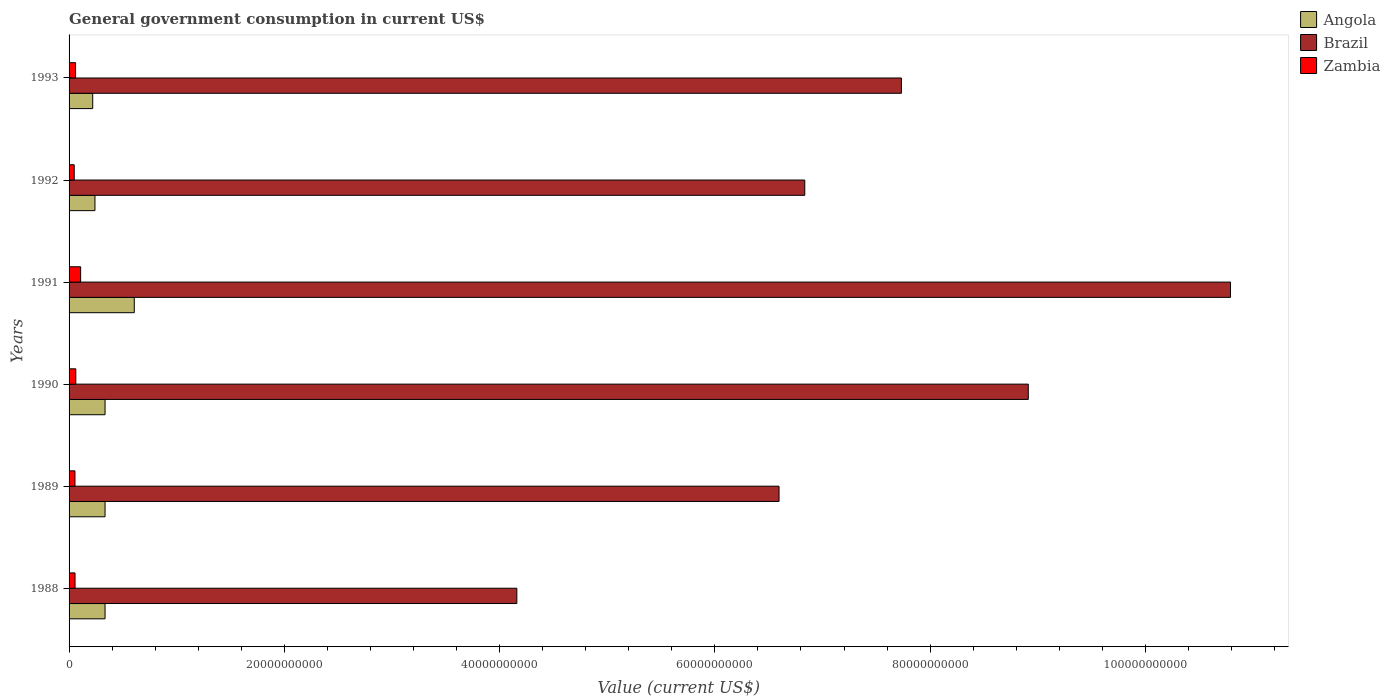Are the number of bars per tick equal to the number of legend labels?
Your response must be concise. Yes. How many bars are there on the 2nd tick from the top?
Your response must be concise. 3. What is the government conusmption in Angola in 1988?
Offer a terse response. 3.34e+09. Across all years, what is the maximum government conusmption in Zambia?
Offer a terse response. 1.07e+09. Across all years, what is the minimum government conusmption in Zambia?
Your answer should be very brief. 4.78e+08. In which year was the government conusmption in Brazil maximum?
Provide a short and direct response. 1991. What is the total government conusmption in Angola in the graph?
Your answer should be very brief. 2.07e+1. What is the difference between the government conusmption in Zambia in 1988 and that in 1992?
Your answer should be compact. 7.66e+07. What is the difference between the government conusmption in Zambia in 1992 and the government conusmption in Brazil in 1991?
Provide a succinct answer. -1.07e+11. What is the average government conusmption in Zambia per year?
Provide a succinct answer. 6.47e+08. In the year 1989, what is the difference between the government conusmption in Angola and government conusmption in Zambia?
Ensure brevity in your answer.  2.79e+09. What is the ratio of the government conusmption in Brazil in 1989 to that in 1993?
Offer a very short reply. 0.85. What is the difference between the highest and the second highest government conusmption in Zambia?
Give a very brief answer. 4.49e+08. What is the difference between the highest and the lowest government conusmption in Angola?
Ensure brevity in your answer.  3.86e+09. Is the sum of the government conusmption in Brazil in 1989 and 1993 greater than the maximum government conusmption in Angola across all years?
Ensure brevity in your answer.  Yes. What does the 1st bar from the top in 1989 represents?
Ensure brevity in your answer.  Zambia. What does the 1st bar from the bottom in 1989 represents?
Offer a terse response. Angola. Is it the case that in every year, the sum of the government conusmption in Zambia and government conusmption in Brazil is greater than the government conusmption in Angola?
Give a very brief answer. Yes. How many bars are there?
Your response must be concise. 18. Are all the bars in the graph horizontal?
Your answer should be very brief. Yes. What is the difference between two consecutive major ticks on the X-axis?
Provide a short and direct response. 2.00e+1. Are the values on the major ticks of X-axis written in scientific E-notation?
Your response must be concise. No. Does the graph contain any zero values?
Provide a short and direct response. No. Does the graph contain grids?
Provide a succinct answer. No. How many legend labels are there?
Provide a short and direct response. 3. What is the title of the graph?
Your answer should be very brief. General government consumption in current US$. What is the label or title of the X-axis?
Provide a succinct answer. Value (current US$). What is the Value (current US$) in Angola in 1988?
Provide a succinct answer. 3.34e+09. What is the Value (current US$) of Brazil in 1988?
Offer a very short reply. 4.16e+1. What is the Value (current US$) of Zambia in 1988?
Your response must be concise. 5.54e+08. What is the Value (current US$) in Angola in 1989?
Provide a short and direct response. 3.34e+09. What is the Value (current US$) of Brazil in 1989?
Provide a short and direct response. 6.60e+1. What is the Value (current US$) of Zambia in 1989?
Make the answer very short. 5.48e+08. What is the Value (current US$) of Angola in 1990?
Your answer should be very brief. 3.34e+09. What is the Value (current US$) of Brazil in 1990?
Your answer should be very brief. 8.91e+1. What is the Value (current US$) in Zambia in 1990?
Keep it short and to the point. 6.26e+08. What is the Value (current US$) in Angola in 1991?
Ensure brevity in your answer.  6.06e+09. What is the Value (current US$) of Brazil in 1991?
Your answer should be compact. 1.08e+11. What is the Value (current US$) in Zambia in 1991?
Offer a terse response. 1.07e+09. What is the Value (current US$) in Angola in 1992?
Your answer should be compact. 2.40e+09. What is the Value (current US$) of Brazil in 1992?
Give a very brief answer. 6.84e+1. What is the Value (current US$) in Zambia in 1992?
Your response must be concise. 4.78e+08. What is the Value (current US$) in Angola in 1993?
Keep it short and to the point. 2.20e+09. What is the Value (current US$) of Brazil in 1993?
Provide a succinct answer. 7.73e+1. What is the Value (current US$) of Zambia in 1993?
Provide a succinct answer. 6.03e+08. Across all years, what is the maximum Value (current US$) of Angola?
Keep it short and to the point. 6.06e+09. Across all years, what is the maximum Value (current US$) in Brazil?
Keep it short and to the point. 1.08e+11. Across all years, what is the maximum Value (current US$) in Zambia?
Your answer should be very brief. 1.07e+09. Across all years, what is the minimum Value (current US$) of Angola?
Your answer should be very brief. 2.20e+09. Across all years, what is the minimum Value (current US$) of Brazil?
Offer a very short reply. 4.16e+1. Across all years, what is the minimum Value (current US$) in Zambia?
Offer a terse response. 4.78e+08. What is the total Value (current US$) of Angola in the graph?
Ensure brevity in your answer.  2.07e+1. What is the total Value (current US$) of Brazil in the graph?
Your answer should be compact. 4.50e+11. What is the total Value (current US$) of Zambia in the graph?
Offer a terse response. 3.88e+09. What is the difference between the Value (current US$) of Angola in 1988 and that in 1989?
Ensure brevity in your answer.  0. What is the difference between the Value (current US$) in Brazil in 1988 and that in 1989?
Provide a short and direct response. -2.44e+1. What is the difference between the Value (current US$) in Zambia in 1988 and that in 1989?
Ensure brevity in your answer.  6.05e+06. What is the difference between the Value (current US$) of Angola in 1988 and that in 1990?
Provide a succinct answer. 0. What is the difference between the Value (current US$) in Brazil in 1988 and that in 1990?
Ensure brevity in your answer.  -4.75e+1. What is the difference between the Value (current US$) in Zambia in 1988 and that in 1990?
Give a very brief answer. -7.13e+07. What is the difference between the Value (current US$) in Angola in 1988 and that in 1991?
Offer a terse response. -2.72e+09. What is the difference between the Value (current US$) of Brazil in 1988 and that in 1991?
Give a very brief answer. -6.63e+1. What is the difference between the Value (current US$) of Zambia in 1988 and that in 1991?
Your answer should be compact. -5.20e+08. What is the difference between the Value (current US$) of Angola in 1988 and that in 1992?
Offer a terse response. 9.37e+08. What is the difference between the Value (current US$) of Brazil in 1988 and that in 1992?
Keep it short and to the point. -2.68e+1. What is the difference between the Value (current US$) in Zambia in 1988 and that in 1992?
Give a very brief answer. 7.66e+07. What is the difference between the Value (current US$) in Angola in 1988 and that in 1993?
Give a very brief answer. 1.14e+09. What is the difference between the Value (current US$) of Brazil in 1988 and that in 1993?
Provide a short and direct response. -3.57e+1. What is the difference between the Value (current US$) in Zambia in 1988 and that in 1993?
Provide a succinct answer. -4.89e+07. What is the difference between the Value (current US$) of Brazil in 1989 and that in 1990?
Keep it short and to the point. -2.32e+1. What is the difference between the Value (current US$) in Zambia in 1989 and that in 1990?
Your response must be concise. -7.74e+07. What is the difference between the Value (current US$) in Angola in 1989 and that in 1991?
Offer a terse response. -2.72e+09. What is the difference between the Value (current US$) of Brazil in 1989 and that in 1991?
Offer a terse response. -4.19e+1. What is the difference between the Value (current US$) in Zambia in 1989 and that in 1991?
Offer a terse response. -5.26e+08. What is the difference between the Value (current US$) in Angola in 1989 and that in 1992?
Offer a very short reply. 9.37e+08. What is the difference between the Value (current US$) of Brazil in 1989 and that in 1992?
Offer a terse response. -2.39e+09. What is the difference between the Value (current US$) of Zambia in 1989 and that in 1992?
Your answer should be compact. 7.05e+07. What is the difference between the Value (current US$) of Angola in 1989 and that in 1993?
Provide a short and direct response. 1.14e+09. What is the difference between the Value (current US$) of Brazil in 1989 and that in 1993?
Provide a short and direct response. -1.14e+1. What is the difference between the Value (current US$) of Zambia in 1989 and that in 1993?
Offer a terse response. -5.50e+07. What is the difference between the Value (current US$) of Angola in 1990 and that in 1991?
Offer a terse response. -2.72e+09. What is the difference between the Value (current US$) of Brazil in 1990 and that in 1991?
Offer a very short reply. -1.88e+1. What is the difference between the Value (current US$) in Zambia in 1990 and that in 1991?
Your answer should be compact. -4.49e+08. What is the difference between the Value (current US$) of Angola in 1990 and that in 1992?
Offer a very short reply. 9.37e+08. What is the difference between the Value (current US$) of Brazil in 1990 and that in 1992?
Give a very brief answer. 2.08e+1. What is the difference between the Value (current US$) in Zambia in 1990 and that in 1992?
Make the answer very short. 1.48e+08. What is the difference between the Value (current US$) in Angola in 1990 and that in 1993?
Make the answer very short. 1.14e+09. What is the difference between the Value (current US$) in Brazil in 1990 and that in 1993?
Your answer should be compact. 1.18e+1. What is the difference between the Value (current US$) of Zambia in 1990 and that in 1993?
Provide a succinct answer. 2.24e+07. What is the difference between the Value (current US$) in Angola in 1991 and that in 1992?
Provide a short and direct response. 3.65e+09. What is the difference between the Value (current US$) in Brazil in 1991 and that in 1992?
Offer a very short reply. 3.96e+1. What is the difference between the Value (current US$) in Zambia in 1991 and that in 1992?
Your answer should be compact. 5.97e+08. What is the difference between the Value (current US$) of Angola in 1991 and that in 1993?
Your answer should be very brief. 3.86e+09. What is the difference between the Value (current US$) in Brazil in 1991 and that in 1993?
Provide a short and direct response. 3.06e+1. What is the difference between the Value (current US$) of Zambia in 1991 and that in 1993?
Your answer should be very brief. 4.71e+08. What is the difference between the Value (current US$) in Angola in 1992 and that in 1993?
Offer a very short reply. 2.07e+08. What is the difference between the Value (current US$) of Brazil in 1992 and that in 1993?
Keep it short and to the point. -8.98e+09. What is the difference between the Value (current US$) of Zambia in 1992 and that in 1993?
Your answer should be compact. -1.26e+08. What is the difference between the Value (current US$) of Angola in 1988 and the Value (current US$) of Brazil in 1989?
Your answer should be compact. -6.26e+1. What is the difference between the Value (current US$) in Angola in 1988 and the Value (current US$) in Zambia in 1989?
Ensure brevity in your answer.  2.79e+09. What is the difference between the Value (current US$) of Brazil in 1988 and the Value (current US$) of Zambia in 1989?
Provide a succinct answer. 4.11e+1. What is the difference between the Value (current US$) of Angola in 1988 and the Value (current US$) of Brazil in 1990?
Make the answer very short. -8.58e+1. What is the difference between the Value (current US$) in Angola in 1988 and the Value (current US$) in Zambia in 1990?
Offer a very short reply. 2.72e+09. What is the difference between the Value (current US$) of Brazil in 1988 and the Value (current US$) of Zambia in 1990?
Provide a succinct answer. 4.10e+1. What is the difference between the Value (current US$) of Angola in 1988 and the Value (current US$) of Brazil in 1991?
Make the answer very short. -1.05e+11. What is the difference between the Value (current US$) of Angola in 1988 and the Value (current US$) of Zambia in 1991?
Ensure brevity in your answer.  2.27e+09. What is the difference between the Value (current US$) in Brazil in 1988 and the Value (current US$) in Zambia in 1991?
Make the answer very short. 4.05e+1. What is the difference between the Value (current US$) in Angola in 1988 and the Value (current US$) in Brazil in 1992?
Your response must be concise. -6.50e+1. What is the difference between the Value (current US$) in Angola in 1988 and the Value (current US$) in Zambia in 1992?
Your answer should be very brief. 2.86e+09. What is the difference between the Value (current US$) of Brazil in 1988 and the Value (current US$) of Zambia in 1992?
Your answer should be compact. 4.11e+1. What is the difference between the Value (current US$) in Angola in 1988 and the Value (current US$) in Brazil in 1993?
Give a very brief answer. -7.40e+1. What is the difference between the Value (current US$) in Angola in 1988 and the Value (current US$) in Zambia in 1993?
Make the answer very short. 2.74e+09. What is the difference between the Value (current US$) in Brazil in 1988 and the Value (current US$) in Zambia in 1993?
Your answer should be compact. 4.10e+1. What is the difference between the Value (current US$) of Angola in 1989 and the Value (current US$) of Brazil in 1990?
Your answer should be compact. -8.58e+1. What is the difference between the Value (current US$) in Angola in 1989 and the Value (current US$) in Zambia in 1990?
Make the answer very short. 2.72e+09. What is the difference between the Value (current US$) in Brazil in 1989 and the Value (current US$) in Zambia in 1990?
Provide a succinct answer. 6.53e+1. What is the difference between the Value (current US$) of Angola in 1989 and the Value (current US$) of Brazil in 1991?
Give a very brief answer. -1.05e+11. What is the difference between the Value (current US$) in Angola in 1989 and the Value (current US$) in Zambia in 1991?
Make the answer very short. 2.27e+09. What is the difference between the Value (current US$) of Brazil in 1989 and the Value (current US$) of Zambia in 1991?
Ensure brevity in your answer.  6.49e+1. What is the difference between the Value (current US$) in Angola in 1989 and the Value (current US$) in Brazil in 1992?
Your answer should be compact. -6.50e+1. What is the difference between the Value (current US$) in Angola in 1989 and the Value (current US$) in Zambia in 1992?
Your answer should be compact. 2.86e+09. What is the difference between the Value (current US$) of Brazil in 1989 and the Value (current US$) of Zambia in 1992?
Keep it short and to the point. 6.55e+1. What is the difference between the Value (current US$) of Angola in 1989 and the Value (current US$) of Brazil in 1993?
Keep it short and to the point. -7.40e+1. What is the difference between the Value (current US$) of Angola in 1989 and the Value (current US$) of Zambia in 1993?
Your answer should be very brief. 2.74e+09. What is the difference between the Value (current US$) in Brazil in 1989 and the Value (current US$) in Zambia in 1993?
Offer a terse response. 6.54e+1. What is the difference between the Value (current US$) of Angola in 1990 and the Value (current US$) of Brazil in 1991?
Give a very brief answer. -1.05e+11. What is the difference between the Value (current US$) of Angola in 1990 and the Value (current US$) of Zambia in 1991?
Your response must be concise. 2.27e+09. What is the difference between the Value (current US$) of Brazil in 1990 and the Value (current US$) of Zambia in 1991?
Make the answer very short. 8.80e+1. What is the difference between the Value (current US$) in Angola in 1990 and the Value (current US$) in Brazil in 1992?
Give a very brief answer. -6.50e+1. What is the difference between the Value (current US$) of Angola in 1990 and the Value (current US$) of Zambia in 1992?
Provide a succinct answer. 2.86e+09. What is the difference between the Value (current US$) in Brazil in 1990 and the Value (current US$) in Zambia in 1992?
Give a very brief answer. 8.86e+1. What is the difference between the Value (current US$) of Angola in 1990 and the Value (current US$) of Brazil in 1993?
Make the answer very short. -7.40e+1. What is the difference between the Value (current US$) in Angola in 1990 and the Value (current US$) in Zambia in 1993?
Provide a short and direct response. 2.74e+09. What is the difference between the Value (current US$) of Brazil in 1990 and the Value (current US$) of Zambia in 1993?
Keep it short and to the point. 8.85e+1. What is the difference between the Value (current US$) of Angola in 1991 and the Value (current US$) of Brazil in 1992?
Keep it short and to the point. -6.23e+1. What is the difference between the Value (current US$) in Angola in 1991 and the Value (current US$) in Zambia in 1992?
Your answer should be compact. 5.58e+09. What is the difference between the Value (current US$) in Brazil in 1991 and the Value (current US$) in Zambia in 1992?
Keep it short and to the point. 1.07e+11. What is the difference between the Value (current US$) of Angola in 1991 and the Value (current US$) of Brazil in 1993?
Make the answer very short. -7.13e+1. What is the difference between the Value (current US$) in Angola in 1991 and the Value (current US$) in Zambia in 1993?
Provide a succinct answer. 5.46e+09. What is the difference between the Value (current US$) in Brazil in 1991 and the Value (current US$) in Zambia in 1993?
Offer a terse response. 1.07e+11. What is the difference between the Value (current US$) in Angola in 1992 and the Value (current US$) in Brazil in 1993?
Give a very brief answer. -7.49e+1. What is the difference between the Value (current US$) in Angola in 1992 and the Value (current US$) in Zambia in 1993?
Your answer should be compact. 1.80e+09. What is the difference between the Value (current US$) in Brazil in 1992 and the Value (current US$) in Zambia in 1993?
Keep it short and to the point. 6.78e+1. What is the average Value (current US$) of Angola per year?
Your answer should be compact. 3.45e+09. What is the average Value (current US$) in Brazil per year?
Your response must be concise. 7.50e+1. What is the average Value (current US$) of Zambia per year?
Offer a terse response. 6.47e+08. In the year 1988, what is the difference between the Value (current US$) of Angola and Value (current US$) of Brazil?
Provide a succinct answer. -3.83e+1. In the year 1988, what is the difference between the Value (current US$) in Angola and Value (current US$) in Zambia?
Your answer should be compact. 2.79e+09. In the year 1988, what is the difference between the Value (current US$) of Brazil and Value (current US$) of Zambia?
Ensure brevity in your answer.  4.10e+1. In the year 1989, what is the difference between the Value (current US$) of Angola and Value (current US$) of Brazil?
Your answer should be very brief. -6.26e+1. In the year 1989, what is the difference between the Value (current US$) of Angola and Value (current US$) of Zambia?
Provide a short and direct response. 2.79e+09. In the year 1989, what is the difference between the Value (current US$) of Brazil and Value (current US$) of Zambia?
Keep it short and to the point. 6.54e+1. In the year 1990, what is the difference between the Value (current US$) of Angola and Value (current US$) of Brazil?
Provide a succinct answer. -8.58e+1. In the year 1990, what is the difference between the Value (current US$) in Angola and Value (current US$) in Zambia?
Provide a succinct answer. 2.72e+09. In the year 1990, what is the difference between the Value (current US$) of Brazil and Value (current US$) of Zambia?
Offer a very short reply. 8.85e+1. In the year 1991, what is the difference between the Value (current US$) in Angola and Value (current US$) in Brazil?
Your answer should be very brief. -1.02e+11. In the year 1991, what is the difference between the Value (current US$) in Angola and Value (current US$) in Zambia?
Make the answer very short. 4.98e+09. In the year 1991, what is the difference between the Value (current US$) of Brazil and Value (current US$) of Zambia?
Provide a short and direct response. 1.07e+11. In the year 1992, what is the difference between the Value (current US$) of Angola and Value (current US$) of Brazil?
Your answer should be very brief. -6.59e+1. In the year 1992, what is the difference between the Value (current US$) of Angola and Value (current US$) of Zambia?
Keep it short and to the point. 1.93e+09. In the year 1992, what is the difference between the Value (current US$) of Brazil and Value (current US$) of Zambia?
Your answer should be compact. 6.79e+1. In the year 1993, what is the difference between the Value (current US$) in Angola and Value (current US$) in Brazil?
Give a very brief answer. -7.51e+1. In the year 1993, what is the difference between the Value (current US$) in Angola and Value (current US$) in Zambia?
Keep it short and to the point. 1.59e+09. In the year 1993, what is the difference between the Value (current US$) in Brazil and Value (current US$) in Zambia?
Ensure brevity in your answer.  7.67e+1. What is the ratio of the Value (current US$) of Angola in 1988 to that in 1989?
Your answer should be compact. 1. What is the ratio of the Value (current US$) of Brazil in 1988 to that in 1989?
Give a very brief answer. 0.63. What is the ratio of the Value (current US$) in Angola in 1988 to that in 1990?
Offer a very short reply. 1. What is the ratio of the Value (current US$) of Brazil in 1988 to that in 1990?
Offer a very short reply. 0.47. What is the ratio of the Value (current US$) of Zambia in 1988 to that in 1990?
Offer a very short reply. 0.89. What is the ratio of the Value (current US$) of Angola in 1988 to that in 1991?
Provide a short and direct response. 0.55. What is the ratio of the Value (current US$) of Brazil in 1988 to that in 1991?
Offer a very short reply. 0.39. What is the ratio of the Value (current US$) of Zambia in 1988 to that in 1991?
Make the answer very short. 0.52. What is the ratio of the Value (current US$) of Angola in 1988 to that in 1992?
Make the answer very short. 1.39. What is the ratio of the Value (current US$) of Brazil in 1988 to that in 1992?
Offer a terse response. 0.61. What is the ratio of the Value (current US$) of Zambia in 1988 to that in 1992?
Provide a short and direct response. 1.16. What is the ratio of the Value (current US$) in Angola in 1988 to that in 1993?
Ensure brevity in your answer.  1.52. What is the ratio of the Value (current US$) in Brazil in 1988 to that in 1993?
Make the answer very short. 0.54. What is the ratio of the Value (current US$) in Zambia in 1988 to that in 1993?
Your response must be concise. 0.92. What is the ratio of the Value (current US$) of Angola in 1989 to that in 1990?
Offer a terse response. 1. What is the ratio of the Value (current US$) in Brazil in 1989 to that in 1990?
Make the answer very short. 0.74. What is the ratio of the Value (current US$) in Zambia in 1989 to that in 1990?
Your answer should be compact. 0.88. What is the ratio of the Value (current US$) of Angola in 1989 to that in 1991?
Give a very brief answer. 0.55. What is the ratio of the Value (current US$) in Brazil in 1989 to that in 1991?
Your answer should be very brief. 0.61. What is the ratio of the Value (current US$) of Zambia in 1989 to that in 1991?
Ensure brevity in your answer.  0.51. What is the ratio of the Value (current US$) in Angola in 1989 to that in 1992?
Keep it short and to the point. 1.39. What is the ratio of the Value (current US$) of Zambia in 1989 to that in 1992?
Make the answer very short. 1.15. What is the ratio of the Value (current US$) in Angola in 1989 to that in 1993?
Make the answer very short. 1.52. What is the ratio of the Value (current US$) of Brazil in 1989 to that in 1993?
Give a very brief answer. 0.85. What is the ratio of the Value (current US$) of Zambia in 1989 to that in 1993?
Your answer should be very brief. 0.91. What is the ratio of the Value (current US$) in Angola in 1990 to that in 1991?
Make the answer very short. 0.55. What is the ratio of the Value (current US$) in Brazil in 1990 to that in 1991?
Ensure brevity in your answer.  0.83. What is the ratio of the Value (current US$) in Zambia in 1990 to that in 1991?
Offer a very short reply. 0.58. What is the ratio of the Value (current US$) of Angola in 1990 to that in 1992?
Give a very brief answer. 1.39. What is the ratio of the Value (current US$) of Brazil in 1990 to that in 1992?
Offer a very short reply. 1.3. What is the ratio of the Value (current US$) of Zambia in 1990 to that in 1992?
Your answer should be very brief. 1.31. What is the ratio of the Value (current US$) in Angola in 1990 to that in 1993?
Your answer should be compact. 1.52. What is the ratio of the Value (current US$) of Brazil in 1990 to that in 1993?
Provide a short and direct response. 1.15. What is the ratio of the Value (current US$) of Zambia in 1990 to that in 1993?
Make the answer very short. 1.04. What is the ratio of the Value (current US$) of Angola in 1991 to that in 1992?
Offer a terse response. 2.52. What is the ratio of the Value (current US$) in Brazil in 1991 to that in 1992?
Offer a very short reply. 1.58. What is the ratio of the Value (current US$) of Zambia in 1991 to that in 1992?
Your response must be concise. 2.25. What is the ratio of the Value (current US$) in Angola in 1991 to that in 1993?
Your answer should be very brief. 2.76. What is the ratio of the Value (current US$) of Brazil in 1991 to that in 1993?
Your response must be concise. 1.4. What is the ratio of the Value (current US$) of Zambia in 1991 to that in 1993?
Keep it short and to the point. 1.78. What is the ratio of the Value (current US$) of Angola in 1992 to that in 1993?
Give a very brief answer. 1.09. What is the ratio of the Value (current US$) of Brazil in 1992 to that in 1993?
Make the answer very short. 0.88. What is the ratio of the Value (current US$) in Zambia in 1992 to that in 1993?
Offer a terse response. 0.79. What is the difference between the highest and the second highest Value (current US$) of Angola?
Your answer should be compact. 2.72e+09. What is the difference between the highest and the second highest Value (current US$) in Brazil?
Offer a terse response. 1.88e+1. What is the difference between the highest and the second highest Value (current US$) in Zambia?
Offer a terse response. 4.49e+08. What is the difference between the highest and the lowest Value (current US$) of Angola?
Keep it short and to the point. 3.86e+09. What is the difference between the highest and the lowest Value (current US$) in Brazil?
Offer a very short reply. 6.63e+1. What is the difference between the highest and the lowest Value (current US$) in Zambia?
Keep it short and to the point. 5.97e+08. 